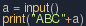<code> <loc_0><loc_0><loc_500><loc_500><_Python_>a = input()
print("ABC"+a)</code> 